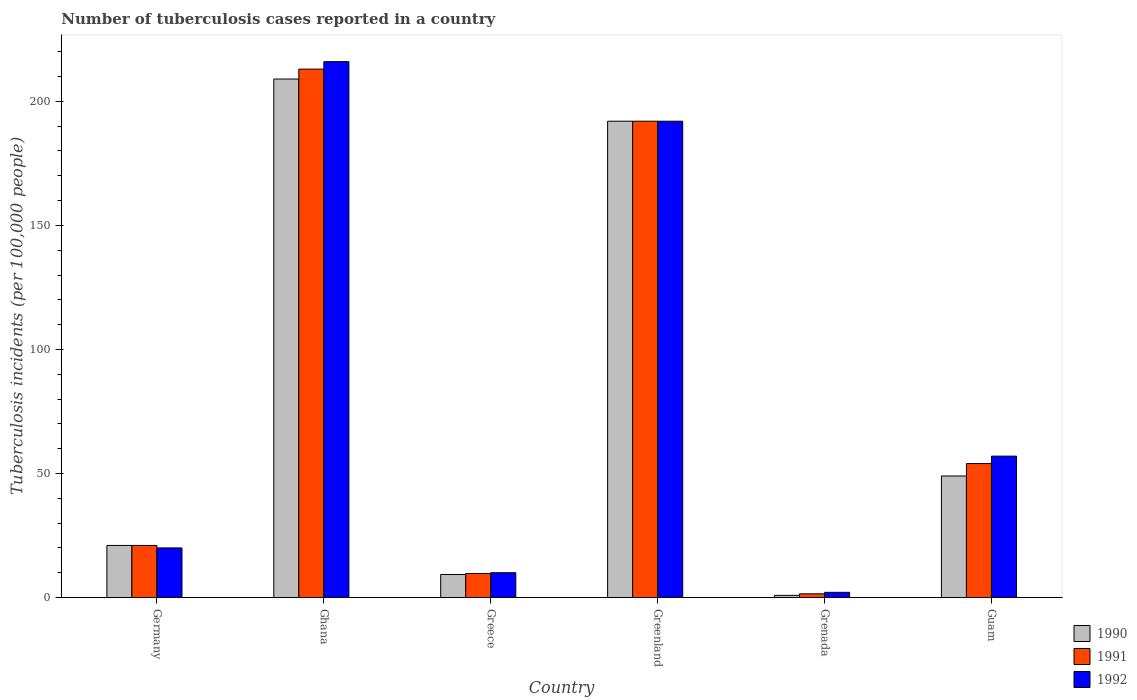How many different coloured bars are there?
Ensure brevity in your answer.  3. Are the number of bars on each tick of the X-axis equal?
Keep it short and to the point. Yes. How many bars are there on the 6th tick from the left?
Provide a succinct answer. 3. How many bars are there on the 5th tick from the right?
Provide a short and direct response. 3. What is the label of the 5th group of bars from the left?
Make the answer very short. Grenada. What is the number of tuberculosis cases reported in in 1991 in Greenland?
Make the answer very short. 192. Across all countries, what is the maximum number of tuberculosis cases reported in in 1991?
Your answer should be very brief. 213. Across all countries, what is the minimum number of tuberculosis cases reported in in 1992?
Offer a terse response. 2.1. In which country was the number of tuberculosis cases reported in in 1991 maximum?
Provide a succinct answer. Ghana. In which country was the number of tuberculosis cases reported in in 1992 minimum?
Your answer should be very brief. Grenada. What is the total number of tuberculosis cases reported in in 1992 in the graph?
Offer a terse response. 497.1. What is the difference between the number of tuberculosis cases reported in in 1990 in Guam and the number of tuberculosis cases reported in in 1992 in Grenada?
Ensure brevity in your answer.  46.9. What is the average number of tuberculosis cases reported in in 1992 per country?
Your response must be concise. 82.85. What is the difference between the number of tuberculosis cases reported in of/in 1990 and number of tuberculosis cases reported in of/in 1991 in Grenada?
Give a very brief answer. -0.62. Is the difference between the number of tuberculosis cases reported in in 1990 in Germany and Guam greater than the difference between the number of tuberculosis cases reported in in 1991 in Germany and Guam?
Your answer should be compact. Yes. What is the difference between the highest and the second highest number of tuberculosis cases reported in in 1991?
Give a very brief answer. -21. What is the difference between the highest and the lowest number of tuberculosis cases reported in in 1990?
Provide a succinct answer. 208.12. In how many countries, is the number of tuberculosis cases reported in in 1991 greater than the average number of tuberculosis cases reported in in 1991 taken over all countries?
Provide a succinct answer. 2. Is it the case that in every country, the sum of the number of tuberculosis cases reported in in 1991 and number of tuberculosis cases reported in in 1990 is greater than the number of tuberculosis cases reported in in 1992?
Your answer should be compact. Yes. How many bars are there?
Offer a very short reply. 18. Are the values on the major ticks of Y-axis written in scientific E-notation?
Provide a succinct answer. No. Does the graph contain grids?
Make the answer very short. No. Where does the legend appear in the graph?
Make the answer very short. Bottom right. How many legend labels are there?
Give a very brief answer. 3. What is the title of the graph?
Keep it short and to the point. Number of tuberculosis cases reported in a country. Does "2005" appear as one of the legend labels in the graph?
Give a very brief answer. No. What is the label or title of the Y-axis?
Give a very brief answer. Tuberculosis incidents (per 100,0 people). What is the Tuberculosis incidents (per 100,000 people) in 1990 in Germany?
Offer a very short reply. 21. What is the Tuberculosis incidents (per 100,000 people) in 1991 in Germany?
Keep it short and to the point. 21. What is the Tuberculosis incidents (per 100,000 people) of 1992 in Germany?
Your answer should be compact. 20. What is the Tuberculosis incidents (per 100,000 people) of 1990 in Ghana?
Offer a terse response. 209. What is the Tuberculosis incidents (per 100,000 people) of 1991 in Ghana?
Make the answer very short. 213. What is the Tuberculosis incidents (per 100,000 people) of 1992 in Ghana?
Your answer should be very brief. 216. What is the Tuberculosis incidents (per 100,000 people) of 1991 in Greece?
Provide a short and direct response. 9.7. What is the Tuberculosis incidents (per 100,000 people) of 1992 in Greece?
Give a very brief answer. 10. What is the Tuberculosis incidents (per 100,000 people) of 1990 in Greenland?
Provide a short and direct response. 192. What is the Tuberculosis incidents (per 100,000 people) of 1991 in Greenland?
Your answer should be compact. 192. What is the Tuberculosis incidents (per 100,000 people) of 1992 in Greenland?
Ensure brevity in your answer.  192. What is the Tuberculosis incidents (per 100,000 people) in 1991 in Grenada?
Your answer should be compact. 1.5. What is the Tuberculosis incidents (per 100,000 people) in 1991 in Guam?
Your answer should be compact. 54. What is the Tuberculosis incidents (per 100,000 people) of 1992 in Guam?
Your answer should be very brief. 57. Across all countries, what is the maximum Tuberculosis incidents (per 100,000 people) of 1990?
Give a very brief answer. 209. Across all countries, what is the maximum Tuberculosis incidents (per 100,000 people) in 1991?
Your response must be concise. 213. Across all countries, what is the maximum Tuberculosis incidents (per 100,000 people) of 1992?
Keep it short and to the point. 216. Across all countries, what is the minimum Tuberculosis incidents (per 100,000 people) of 1990?
Your answer should be very brief. 0.88. What is the total Tuberculosis incidents (per 100,000 people) in 1990 in the graph?
Provide a succinct answer. 481.18. What is the total Tuberculosis incidents (per 100,000 people) in 1991 in the graph?
Ensure brevity in your answer.  491.2. What is the total Tuberculosis incidents (per 100,000 people) in 1992 in the graph?
Keep it short and to the point. 497.1. What is the difference between the Tuberculosis incidents (per 100,000 people) of 1990 in Germany and that in Ghana?
Ensure brevity in your answer.  -188. What is the difference between the Tuberculosis incidents (per 100,000 people) in 1991 in Germany and that in Ghana?
Your answer should be compact. -192. What is the difference between the Tuberculosis incidents (per 100,000 people) of 1992 in Germany and that in Ghana?
Your response must be concise. -196. What is the difference between the Tuberculosis incidents (per 100,000 people) in 1990 in Germany and that in Greenland?
Keep it short and to the point. -171. What is the difference between the Tuberculosis incidents (per 100,000 people) of 1991 in Germany and that in Greenland?
Offer a very short reply. -171. What is the difference between the Tuberculosis incidents (per 100,000 people) in 1992 in Germany and that in Greenland?
Your answer should be very brief. -172. What is the difference between the Tuberculosis incidents (per 100,000 people) of 1990 in Germany and that in Grenada?
Offer a very short reply. 20.12. What is the difference between the Tuberculosis incidents (per 100,000 people) in 1991 in Germany and that in Grenada?
Ensure brevity in your answer.  19.5. What is the difference between the Tuberculosis incidents (per 100,000 people) of 1990 in Germany and that in Guam?
Offer a very short reply. -28. What is the difference between the Tuberculosis incidents (per 100,000 people) of 1991 in Germany and that in Guam?
Keep it short and to the point. -33. What is the difference between the Tuberculosis incidents (per 100,000 people) of 1992 in Germany and that in Guam?
Ensure brevity in your answer.  -37. What is the difference between the Tuberculosis incidents (per 100,000 people) in 1990 in Ghana and that in Greece?
Provide a succinct answer. 199.7. What is the difference between the Tuberculosis incidents (per 100,000 people) in 1991 in Ghana and that in Greece?
Your answer should be compact. 203.3. What is the difference between the Tuberculosis incidents (per 100,000 people) in 1992 in Ghana and that in Greece?
Provide a succinct answer. 206. What is the difference between the Tuberculosis incidents (per 100,000 people) of 1990 in Ghana and that in Greenland?
Give a very brief answer. 17. What is the difference between the Tuberculosis incidents (per 100,000 people) in 1990 in Ghana and that in Grenada?
Keep it short and to the point. 208.12. What is the difference between the Tuberculosis incidents (per 100,000 people) in 1991 in Ghana and that in Grenada?
Make the answer very short. 211.5. What is the difference between the Tuberculosis incidents (per 100,000 people) of 1992 in Ghana and that in Grenada?
Keep it short and to the point. 213.9. What is the difference between the Tuberculosis incidents (per 100,000 people) in 1990 in Ghana and that in Guam?
Provide a succinct answer. 160. What is the difference between the Tuberculosis incidents (per 100,000 people) of 1991 in Ghana and that in Guam?
Your answer should be compact. 159. What is the difference between the Tuberculosis incidents (per 100,000 people) of 1992 in Ghana and that in Guam?
Your answer should be very brief. 159. What is the difference between the Tuberculosis incidents (per 100,000 people) of 1990 in Greece and that in Greenland?
Offer a terse response. -182.7. What is the difference between the Tuberculosis incidents (per 100,000 people) in 1991 in Greece and that in Greenland?
Your answer should be very brief. -182.3. What is the difference between the Tuberculosis incidents (per 100,000 people) of 1992 in Greece and that in Greenland?
Provide a short and direct response. -182. What is the difference between the Tuberculosis incidents (per 100,000 people) of 1990 in Greece and that in Grenada?
Your answer should be very brief. 8.42. What is the difference between the Tuberculosis incidents (per 100,000 people) in 1991 in Greece and that in Grenada?
Your answer should be compact. 8.2. What is the difference between the Tuberculosis incidents (per 100,000 people) of 1990 in Greece and that in Guam?
Your response must be concise. -39.7. What is the difference between the Tuberculosis incidents (per 100,000 people) in 1991 in Greece and that in Guam?
Ensure brevity in your answer.  -44.3. What is the difference between the Tuberculosis incidents (per 100,000 people) of 1992 in Greece and that in Guam?
Offer a very short reply. -47. What is the difference between the Tuberculosis incidents (per 100,000 people) in 1990 in Greenland and that in Grenada?
Your answer should be very brief. 191.12. What is the difference between the Tuberculosis incidents (per 100,000 people) of 1991 in Greenland and that in Grenada?
Provide a short and direct response. 190.5. What is the difference between the Tuberculosis incidents (per 100,000 people) in 1992 in Greenland and that in Grenada?
Your response must be concise. 189.9. What is the difference between the Tuberculosis incidents (per 100,000 people) of 1990 in Greenland and that in Guam?
Keep it short and to the point. 143. What is the difference between the Tuberculosis incidents (per 100,000 people) in 1991 in Greenland and that in Guam?
Provide a succinct answer. 138. What is the difference between the Tuberculosis incidents (per 100,000 people) in 1992 in Greenland and that in Guam?
Provide a short and direct response. 135. What is the difference between the Tuberculosis incidents (per 100,000 people) of 1990 in Grenada and that in Guam?
Provide a short and direct response. -48.12. What is the difference between the Tuberculosis incidents (per 100,000 people) of 1991 in Grenada and that in Guam?
Offer a terse response. -52.5. What is the difference between the Tuberculosis incidents (per 100,000 people) in 1992 in Grenada and that in Guam?
Offer a terse response. -54.9. What is the difference between the Tuberculosis incidents (per 100,000 people) in 1990 in Germany and the Tuberculosis incidents (per 100,000 people) in 1991 in Ghana?
Your answer should be compact. -192. What is the difference between the Tuberculosis incidents (per 100,000 people) in 1990 in Germany and the Tuberculosis incidents (per 100,000 people) in 1992 in Ghana?
Ensure brevity in your answer.  -195. What is the difference between the Tuberculosis incidents (per 100,000 people) of 1991 in Germany and the Tuberculosis incidents (per 100,000 people) of 1992 in Ghana?
Make the answer very short. -195. What is the difference between the Tuberculosis incidents (per 100,000 people) of 1990 in Germany and the Tuberculosis incidents (per 100,000 people) of 1991 in Greece?
Ensure brevity in your answer.  11.3. What is the difference between the Tuberculosis incidents (per 100,000 people) in 1990 in Germany and the Tuberculosis incidents (per 100,000 people) in 1992 in Greece?
Give a very brief answer. 11. What is the difference between the Tuberculosis incidents (per 100,000 people) of 1990 in Germany and the Tuberculosis incidents (per 100,000 people) of 1991 in Greenland?
Provide a short and direct response. -171. What is the difference between the Tuberculosis incidents (per 100,000 people) in 1990 in Germany and the Tuberculosis incidents (per 100,000 people) in 1992 in Greenland?
Your answer should be compact. -171. What is the difference between the Tuberculosis incidents (per 100,000 people) of 1991 in Germany and the Tuberculosis incidents (per 100,000 people) of 1992 in Greenland?
Ensure brevity in your answer.  -171. What is the difference between the Tuberculosis incidents (per 100,000 people) in 1990 in Germany and the Tuberculosis incidents (per 100,000 people) in 1992 in Grenada?
Your answer should be very brief. 18.9. What is the difference between the Tuberculosis incidents (per 100,000 people) in 1991 in Germany and the Tuberculosis incidents (per 100,000 people) in 1992 in Grenada?
Make the answer very short. 18.9. What is the difference between the Tuberculosis incidents (per 100,000 people) of 1990 in Germany and the Tuberculosis incidents (per 100,000 people) of 1991 in Guam?
Offer a terse response. -33. What is the difference between the Tuberculosis incidents (per 100,000 people) in 1990 in Germany and the Tuberculosis incidents (per 100,000 people) in 1992 in Guam?
Your response must be concise. -36. What is the difference between the Tuberculosis incidents (per 100,000 people) in 1991 in Germany and the Tuberculosis incidents (per 100,000 people) in 1992 in Guam?
Your answer should be very brief. -36. What is the difference between the Tuberculosis incidents (per 100,000 people) of 1990 in Ghana and the Tuberculosis incidents (per 100,000 people) of 1991 in Greece?
Ensure brevity in your answer.  199.3. What is the difference between the Tuberculosis incidents (per 100,000 people) in 1990 in Ghana and the Tuberculosis incidents (per 100,000 people) in 1992 in Greece?
Offer a terse response. 199. What is the difference between the Tuberculosis incidents (per 100,000 people) of 1991 in Ghana and the Tuberculosis incidents (per 100,000 people) of 1992 in Greece?
Offer a very short reply. 203. What is the difference between the Tuberculosis incidents (per 100,000 people) of 1990 in Ghana and the Tuberculosis incidents (per 100,000 people) of 1991 in Greenland?
Offer a terse response. 17. What is the difference between the Tuberculosis incidents (per 100,000 people) of 1990 in Ghana and the Tuberculosis incidents (per 100,000 people) of 1991 in Grenada?
Give a very brief answer. 207.5. What is the difference between the Tuberculosis incidents (per 100,000 people) of 1990 in Ghana and the Tuberculosis incidents (per 100,000 people) of 1992 in Grenada?
Your answer should be very brief. 206.9. What is the difference between the Tuberculosis incidents (per 100,000 people) of 1991 in Ghana and the Tuberculosis incidents (per 100,000 people) of 1992 in Grenada?
Your answer should be very brief. 210.9. What is the difference between the Tuberculosis incidents (per 100,000 people) of 1990 in Ghana and the Tuberculosis incidents (per 100,000 people) of 1991 in Guam?
Keep it short and to the point. 155. What is the difference between the Tuberculosis incidents (per 100,000 people) in 1990 in Ghana and the Tuberculosis incidents (per 100,000 people) in 1992 in Guam?
Provide a short and direct response. 152. What is the difference between the Tuberculosis incidents (per 100,000 people) in 1991 in Ghana and the Tuberculosis incidents (per 100,000 people) in 1992 in Guam?
Your response must be concise. 156. What is the difference between the Tuberculosis incidents (per 100,000 people) of 1990 in Greece and the Tuberculosis incidents (per 100,000 people) of 1991 in Greenland?
Keep it short and to the point. -182.7. What is the difference between the Tuberculosis incidents (per 100,000 people) of 1990 in Greece and the Tuberculosis incidents (per 100,000 people) of 1992 in Greenland?
Offer a terse response. -182.7. What is the difference between the Tuberculosis incidents (per 100,000 people) of 1991 in Greece and the Tuberculosis incidents (per 100,000 people) of 1992 in Greenland?
Keep it short and to the point. -182.3. What is the difference between the Tuberculosis incidents (per 100,000 people) of 1990 in Greece and the Tuberculosis incidents (per 100,000 people) of 1992 in Grenada?
Keep it short and to the point. 7.2. What is the difference between the Tuberculosis incidents (per 100,000 people) in 1990 in Greece and the Tuberculosis incidents (per 100,000 people) in 1991 in Guam?
Offer a terse response. -44.7. What is the difference between the Tuberculosis incidents (per 100,000 people) of 1990 in Greece and the Tuberculosis incidents (per 100,000 people) of 1992 in Guam?
Your response must be concise. -47.7. What is the difference between the Tuberculosis incidents (per 100,000 people) in 1991 in Greece and the Tuberculosis incidents (per 100,000 people) in 1992 in Guam?
Your answer should be very brief. -47.3. What is the difference between the Tuberculosis incidents (per 100,000 people) of 1990 in Greenland and the Tuberculosis incidents (per 100,000 people) of 1991 in Grenada?
Provide a short and direct response. 190.5. What is the difference between the Tuberculosis incidents (per 100,000 people) in 1990 in Greenland and the Tuberculosis incidents (per 100,000 people) in 1992 in Grenada?
Ensure brevity in your answer.  189.9. What is the difference between the Tuberculosis incidents (per 100,000 people) of 1991 in Greenland and the Tuberculosis incidents (per 100,000 people) of 1992 in Grenada?
Give a very brief answer. 189.9. What is the difference between the Tuberculosis incidents (per 100,000 people) of 1990 in Greenland and the Tuberculosis incidents (per 100,000 people) of 1991 in Guam?
Provide a short and direct response. 138. What is the difference between the Tuberculosis incidents (per 100,000 people) in 1990 in Greenland and the Tuberculosis incidents (per 100,000 people) in 1992 in Guam?
Your response must be concise. 135. What is the difference between the Tuberculosis incidents (per 100,000 people) in 1991 in Greenland and the Tuberculosis incidents (per 100,000 people) in 1992 in Guam?
Your answer should be very brief. 135. What is the difference between the Tuberculosis incidents (per 100,000 people) in 1990 in Grenada and the Tuberculosis incidents (per 100,000 people) in 1991 in Guam?
Ensure brevity in your answer.  -53.12. What is the difference between the Tuberculosis incidents (per 100,000 people) in 1990 in Grenada and the Tuberculosis incidents (per 100,000 people) in 1992 in Guam?
Keep it short and to the point. -56.12. What is the difference between the Tuberculosis incidents (per 100,000 people) of 1991 in Grenada and the Tuberculosis incidents (per 100,000 people) of 1992 in Guam?
Offer a very short reply. -55.5. What is the average Tuberculosis incidents (per 100,000 people) of 1990 per country?
Give a very brief answer. 80.2. What is the average Tuberculosis incidents (per 100,000 people) in 1991 per country?
Make the answer very short. 81.87. What is the average Tuberculosis incidents (per 100,000 people) of 1992 per country?
Offer a terse response. 82.85. What is the difference between the Tuberculosis incidents (per 100,000 people) of 1990 and Tuberculosis incidents (per 100,000 people) of 1991 in Ghana?
Make the answer very short. -4. What is the difference between the Tuberculosis incidents (per 100,000 people) of 1990 and Tuberculosis incidents (per 100,000 people) of 1992 in Ghana?
Your response must be concise. -7. What is the difference between the Tuberculosis incidents (per 100,000 people) in 1990 and Tuberculosis incidents (per 100,000 people) in 1992 in Greece?
Your answer should be compact. -0.7. What is the difference between the Tuberculosis incidents (per 100,000 people) of 1991 and Tuberculosis incidents (per 100,000 people) of 1992 in Greece?
Provide a succinct answer. -0.3. What is the difference between the Tuberculosis incidents (per 100,000 people) of 1990 and Tuberculosis incidents (per 100,000 people) of 1991 in Greenland?
Ensure brevity in your answer.  0. What is the difference between the Tuberculosis incidents (per 100,000 people) in 1991 and Tuberculosis incidents (per 100,000 people) in 1992 in Greenland?
Ensure brevity in your answer.  0. What is the difference between the Tuberculosis incidents (per 100,000 people) of 1990 and Tuberculosis incidents (per 100,000 people) of 1991 in Grenada?
Your answer should be compact. -0.62. What is the difference between the Tuberculosis incidents (per 100,000 people) of 1990 and Tuberculosis incidents (per 100,000 people) of 1992 in Grenada?
Provide a short and direct response. -1.22. What is the difference between the Tuberculosis incidents (per 100,000 people) of 1991 and Tuberculosis incidents (per 100,000 people) of 1992 in Grenada?
Offer a terse response. -0.6. What is the difference between the Tuberculosis incidents (per 100,000 people) of 1990 and Tuberculosis incidents (per 100,000 people) of 1991 in Guam?
Make the answer very short. -5. What is the difference between the Tuberculosis incidents (per 100,000 people) in 1990 and Tuberculosis incidents (per 100,000 people) in 1992 in Guam?
Offer a very short reply. -8. What is the difference between the Tuberculosis incidents (per 100,000 people) in 1991 and Tuberculosis incidents (per 100,000 people) in 1992 in Guam?
Your answer should be compact. -3. What is the ratio of the Tuberculosis incidents (per 100,000 people) of 1990 in Germany to that in Ghana?
Make the answer very short. 0.1. What is the ratio of the Tuberculosis incidents (per 100,000 people) in 1991 in Germany to that in Ghana?
Make the answer very short. 0.1. What is the ratio of the Tuberculosis incidents (per 100,000 people) of 1992 in Germany to that in Ghana?
Your response must be concise. 0.09. What is the ratio of the Tuberculosis incidents (per 100,000 people) in 1990 in Germany to that in Greece?
Provide a succinct answer. 2.26. What is the ratio of the Tuberculosis incidents (per 100,000 people) of 1991 in Germany to that in Greece?
Your answer should be very brief. 2.16. What is the ratio of the Tuberculosis incidents (per 100,000 people) of 1992 in Germany to that in Greece?
Provide a succinct answer. 2. What is the ratio of the Tuberculosis incidents (per 100,000 people) of 1990 in Germany to that in Greenland?
Make the answer very short. 0.11. What is the ratio of the Tuberculosis incidents (per 100,000 people) of 1991 in Germany to that in Greenland?
Your response must be concise. 0.11. What is the ratio of the Tuberculosis incidents (per 100,000 people) of 1992 in Germany to that in Greenland?
Provide a short and direct response. 0.1. What is the ratio of the Tuberculosis incidents (per 100,000 people) in 1990 in Germany to that in Grenada?
Provide a succinct answer. 23.86. What is the ratio of the Tuberculosis incidents (per 100,000 people) in 1992 in Germany to that in Grenada?
Your response must be concise. 9.52. What is the ratio of the Tuberculosis incidents (per 100,000 people) in 1990 in Germany to that in Guam?
Provide a short and direct response. 0.43. What is the ratio of the Tuberculosis incidents (per 100,000 people) in 1991 in Germany to that in Guam?
Provide a succinct answer. 0.39. What is the ratio of the Tuberculosis incidents (per 100,000 people) in 1992 in Germany to that in Guam?
Offer a very short reply. 0.35. What is the ratio of the Tuberculosis incidents (per 100,000 people) of 1990 in Ghana to that in Greece?
Your response must be concise. 22.47. What is the ratio of the Tuberculosis incidents (per 100,000 people) in 1991 in Ghana to that in Greece?
Provide a short and direct response. 21.96. What is the ratio of the Tuberculosis incidents (per 100,000 people) in 1992 in Ghana to that in Greece?
Offer a very short reply. 21.6. What is the ratio of the Tuberculosis incidents (per 100,000 people) in 1990 in Ghana to that in Greenland?
Offer a terse response. 1.09. What is the ratio of the Tuberculosis incidents (per 100,000 people) in 1991 in Ghana to that in Greenland?
Keep it short and to the point. 1.11. What is the ratio of the Tuberculosis incidents (per 100,000 people) of 1992 in Ghana to that in Greenland?
Make the answer very short. 1.12. What is the ratio of the Tuberculosis incidents (per 100,000 people) in 1990 in Ghana to that in Grenada?
Your response must be concise. 237.5. What is the ratio of the Tuberculosis incidents (per 100,000 people) in 1991 in Ghana to that in Grenada?
Your response must be concise. 142. What is the ratio of the Tuberculosis incidents (per 100,000 people) in 1992 in Ghana to that in Grenada?
Make the answer very short. 102.86. What is the ratio of the Tuberculosis incidents (per 100,000 people) of 1990 in Ghana to that in Guam?
Provide a short and direct response. 4.27. What is the ratio of the Tuberculosis incidents (per 100,000 people) in 1991 in Ghana to that in Guam?
Give a very brief answer. 3.94. What is the ratio of the Tuberculosis incidents (per 100,000 people) of 1992 in Ghana to that in Guam?
Your answer should be compact. 3.79. What is the ratio of the Tuberculosis incidents (per 100,000 people) of 1990 in Greece to that in Greenland?
Offer a terse response. 0.05. What is the ratio of the Tuberculosis incidents (per 100,000 people) in 1991 in Greece to that in Greenland?
Make the answer very short. 0.05. What is the ratio of the Tuberculosis incidents (per 100,000 people) of 1992 in Greece to that in Greenland?
Offer a terse response. 0.05. What is the ratio of the Tuberculosis incidents (per 100,000 people) of 1990 in Greece to that in Grenada?
Your response must be concise. 10.57. What is the ratio of the Tuberculosis incidents (per 100,000 people) in 1991 in Greece to that in Grenada?
Your answer should be very brief. 6.47. What is the ratio of the Tuberculosis incidents (per 100,000 people) of 1992 in Greece to that in Grenada?
Provide a succinct answer. 4.76. What is the ratio of the Tuberculosis incidents (per 100,000 people) of 1990 in Greece to that in Guam?
Offer a terse response. 0.19. What is the ratio of the Tuberculosis incidents (per 100,000 people) in 1991 in Greece to that in Guam?
Offer a terse response. 0.18. What is the ratio of the Tuberculosis incidents (per 100,000 people) of 1992 in Greece to that in Guam?
Offer a terse response. 0.18. What is the ratio of the Tuberculosis incidents (per 100,000 people) in 1990 in Greenland to that in Grenada?
Keep it short and to the point. 218.18. What is the ratio of the Tuberculosis incidents (per 100,000 people) in 1991 in Greenland to that in Grenada?
Provide a succinct answer. 128. What is the ratio of the Tuberculosis incidents (per 100,000 people) of 1992 in Greenland to that in Grenada?
Offer a very short reply. 91.43. What is the ratio of the Tuberculosis incidents (per 100,000 people) in 1990 in Greenland to that in Guam?
Make the answer very short. 3.92. What is the ratio of the Tuberculosis incidents (per 100,000 people) of 1991 in Greenland to that in Guam?
Your answer should be compact. 3.56. What is the ratio of the Tuberculosis incidents (per 100,000 people) in 1992 in Greenland to that in Guam?
Your answer should be very brief. 3.37. What is the ratio of the Tuberculosis incidents (per 100,000 people) of 1990 in Grenada to that in Guam?
Offer a very short reply. 0.02. What is the ratio of the Tuberculosis incidents (per 100,000 people) of 1991 in Grenada to that in Guam?
Your answer should be very brief. 0.03. What is the ratio of the Tuberculosis incidents (per 100,000 people) in 1992 in Grenada to that in Guam?
Provide a short and direct response. 0.04. What is the difference between the highest and the second highest Tuberculosis incidents (per 100,000 people) in 1992?
Make the answer very short. 24. What is the difference between the highest and the lowest Tuberculosis incidents (per 100,000 people) of 1990?
Make the answer very short. 208.12. What is the difference between the highest and the lowest Tuberculosis incidents (per 100,000 people) of 1991?
Ensure brevity in your answer.  211.5. What is the difference between the highest and the lowest Tuberculosis incidents (per 100,000 people) of 1992?
Your answer should be very brief. 213.9. 